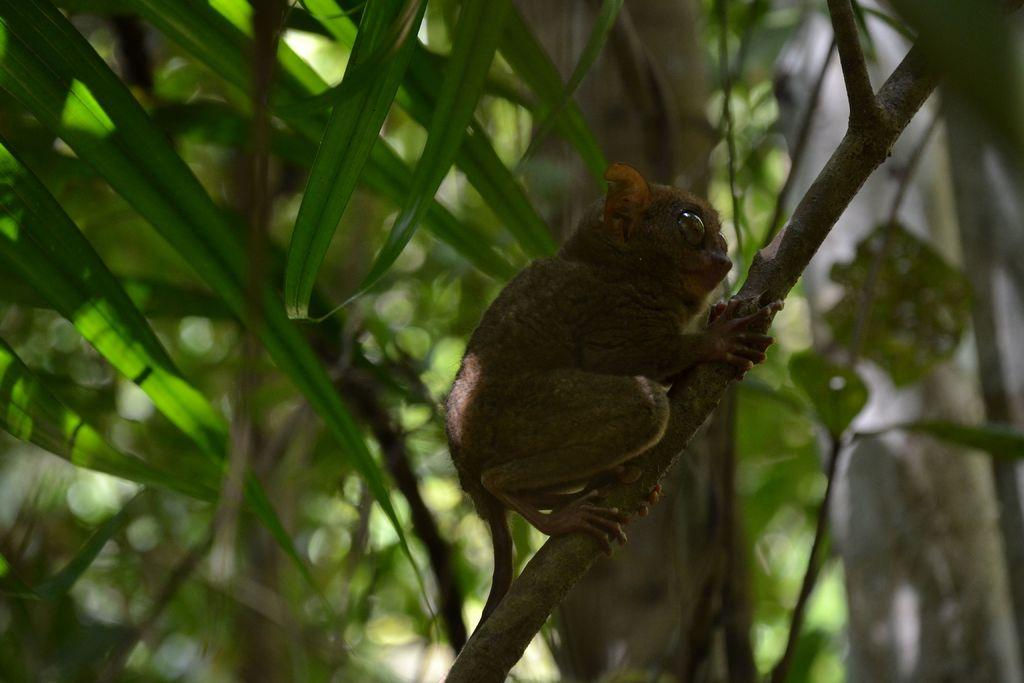What is the main subject of the image? There is an animal on a branch of a tree in the image. Can you describe the setting of the image? The animal is on a branch of a tree, and there are other trees visible in the background of the image. What type of wristwatch is the beast wearing in the image? There is no beast or wristwatch present in the image. 